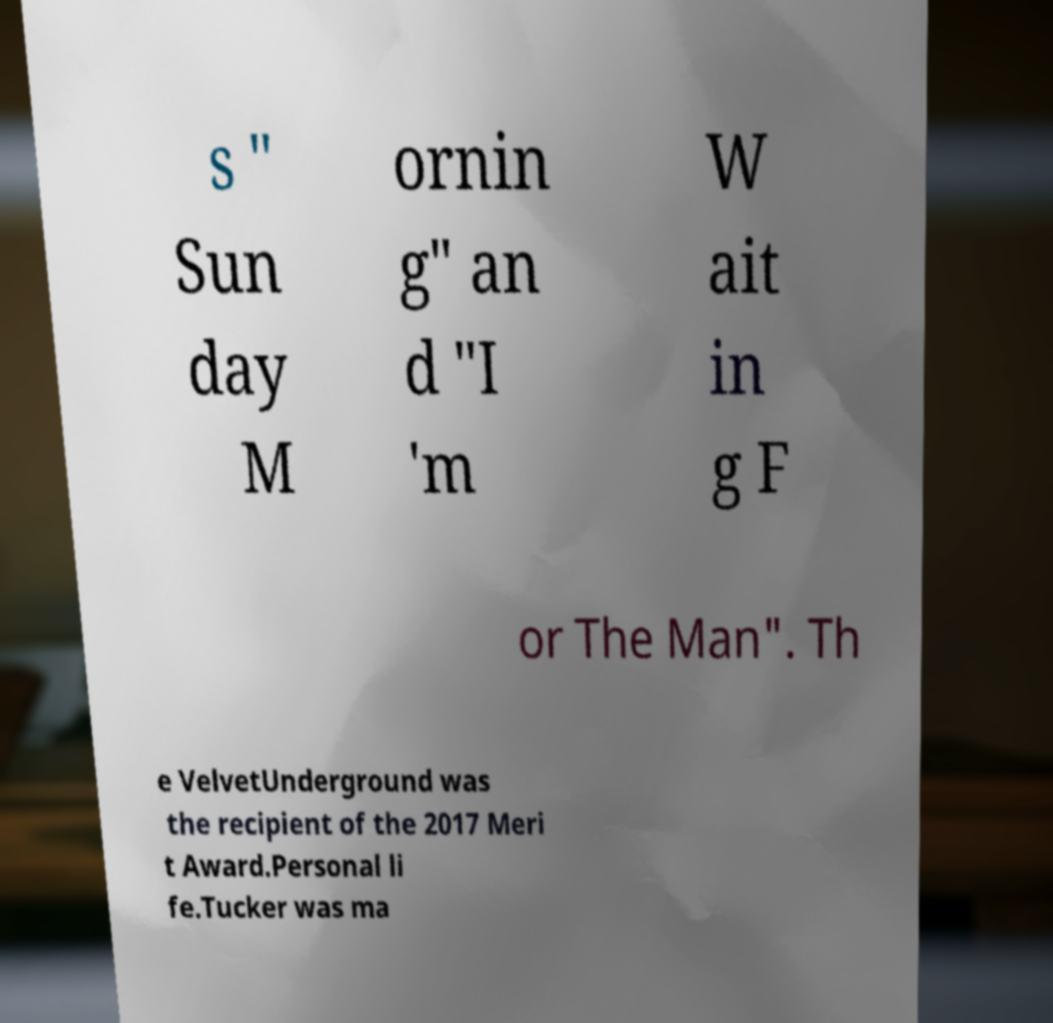I need the written content from this picture converted into text. Can you do that? s " Sun day M ornin g" an d "I 'm W ait in g F or The Man". Th e VelvetUnderground was the recipient of the 2017 Meri t Award.Personal li fe.Tucker was ma 